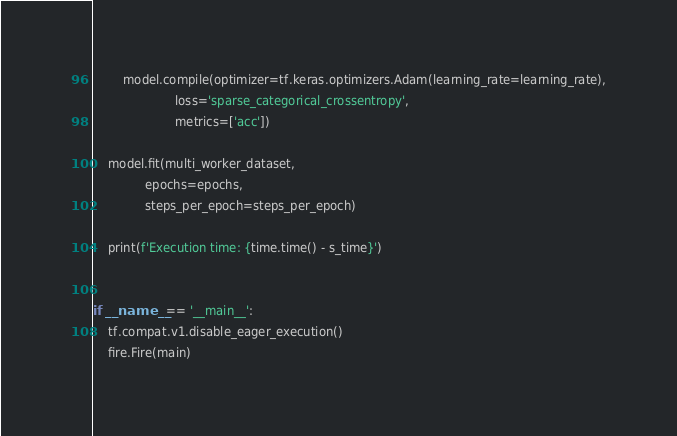<code> <loc_0><loc_0><loc_500><loc_500><_Python_>        model.compile(optimizer=tf.keras.optimizers.Adam(learning_rate=learning_rate),
                      loss='sparse_categorical_crossentropy',
                      metrics=['acc'])

    model.fit(multi_worker_dataset,
              epochs=epochs,
              steps_per_epoch=steps_per_epoch)

    print(f'Execution time: {time.time() - s_time}')


if __name__ == '__main__':
    tf.compat.v1.disable_eager_execution()
    fire.Fire(main)
</code> 